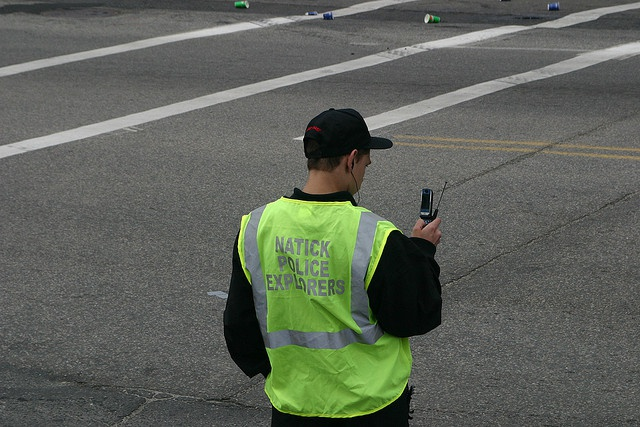Describe the objects in this image and their specific colors. I can see people in gray, black, green, and olive tones, cell phone in gray, black, darkgray, and navy tones, and cup in gray, navy, black, and darkgray tones in this image. 